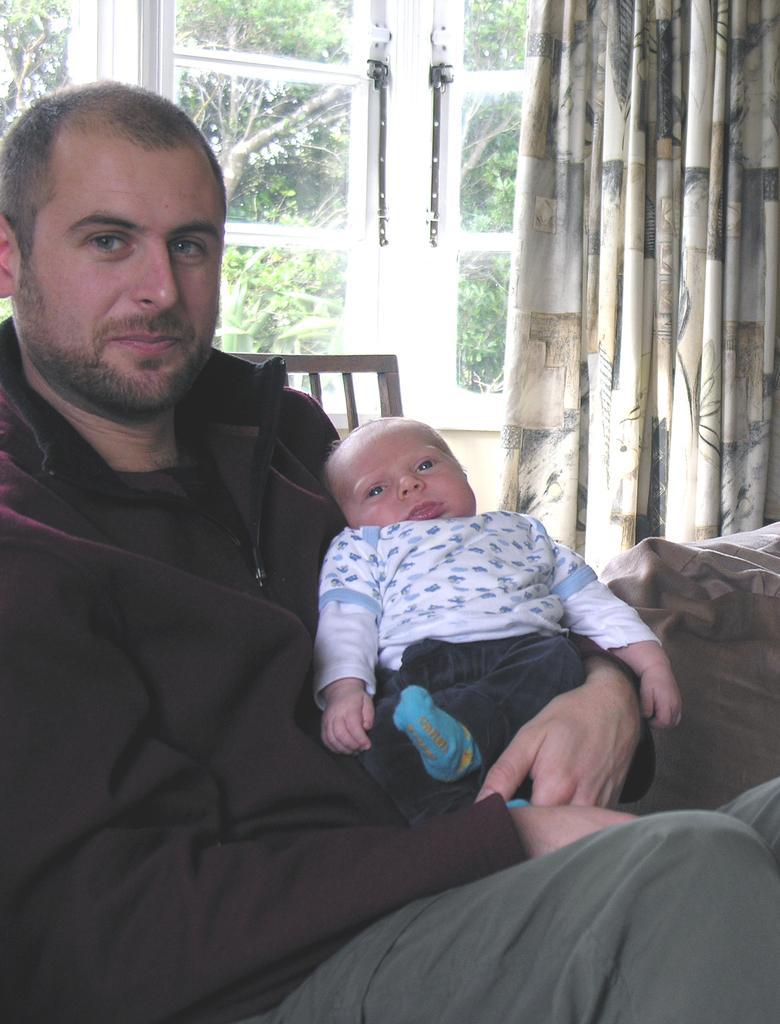Please provide a concise description of this image. In this image I can see a person wearing black colored jacket is sitting on a couch and holding a baby in his lap. In the background I can see the curtain and the window through which I can see few trees. 